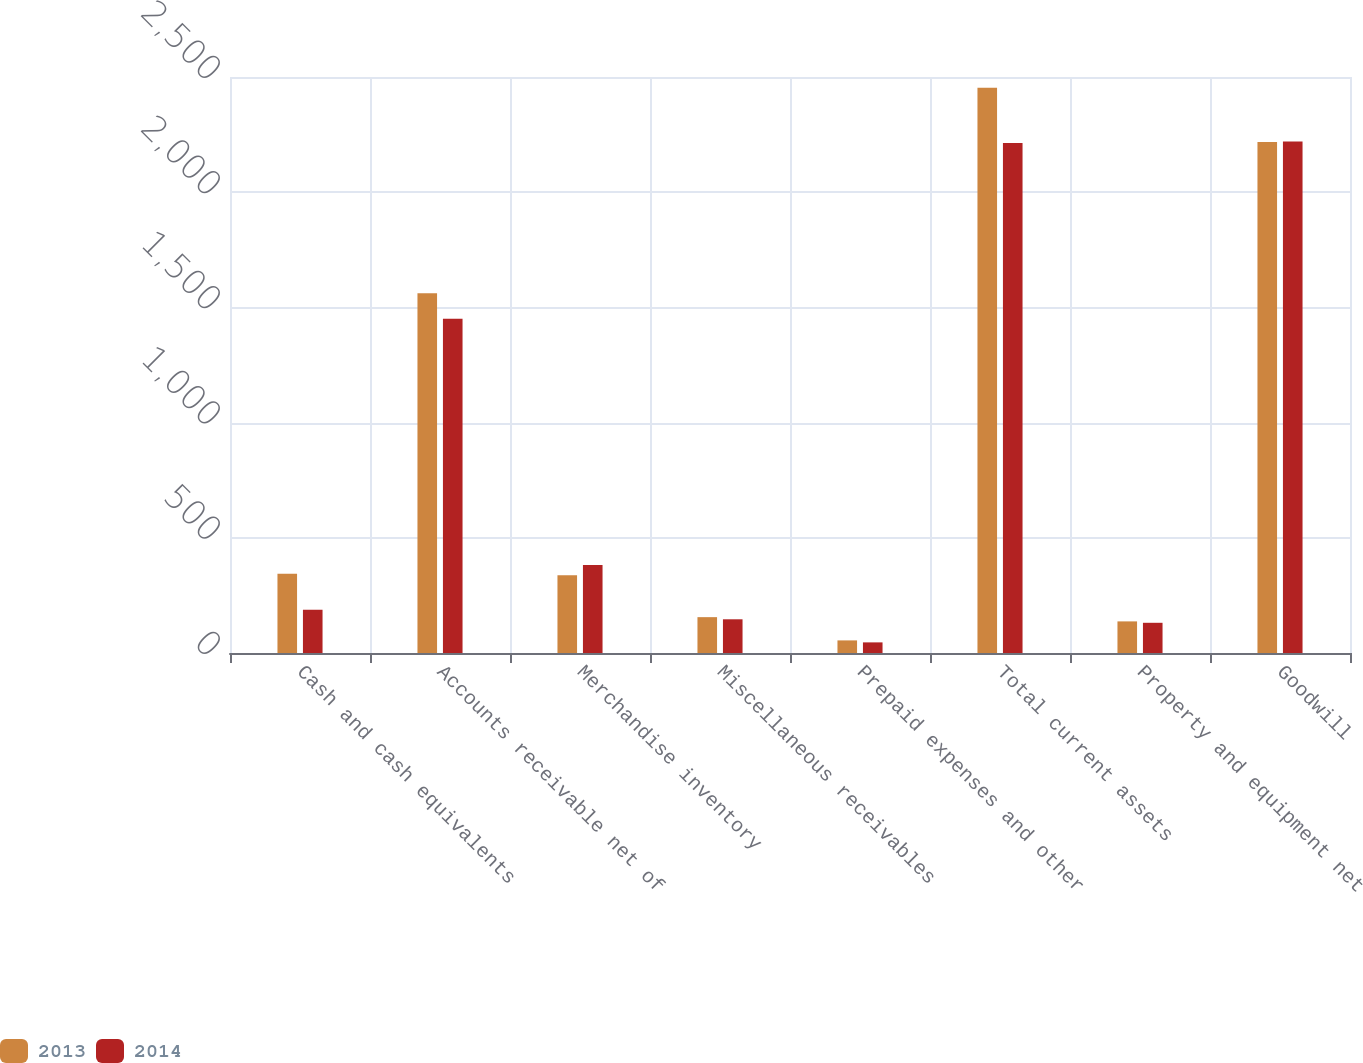<chart> <loc_0><loc_0><loc_500><loc_500><stacked_bar_chart><ecel><fcel>Cash and cash equivalents<fcel>Accounts receivable net of<fcel>Merchandise inventory<fcel>Miscellaneous receivables<fcel>Prepaid expenses and other<fcel>Total current assets<fcel>Property and equipment net<fcel>Goodwill<nl><fcel>2013<fcel>344.5<fcel>1561.1<fcel>337.5<fcel>155.6<fcel>54.7<fcel>2453.4<fcel>137.2<fcel>2217.6<nl><fcel>2014<fcel>188.1<fcel>1451<fcel>382<fcel>146.3<fcel>46.1<fcel>2213.5<fcel>131.1<fcel>2220.3<nl></chart> 